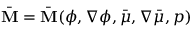Convert formula to latex. <formula><loc_0><loc_0><loc_500><loc_500>\bar { M } = \bar { M } ( \phi , \nabla \phi , \bar { \mu } , \nabla \bar { \mu } , p )</formula> 